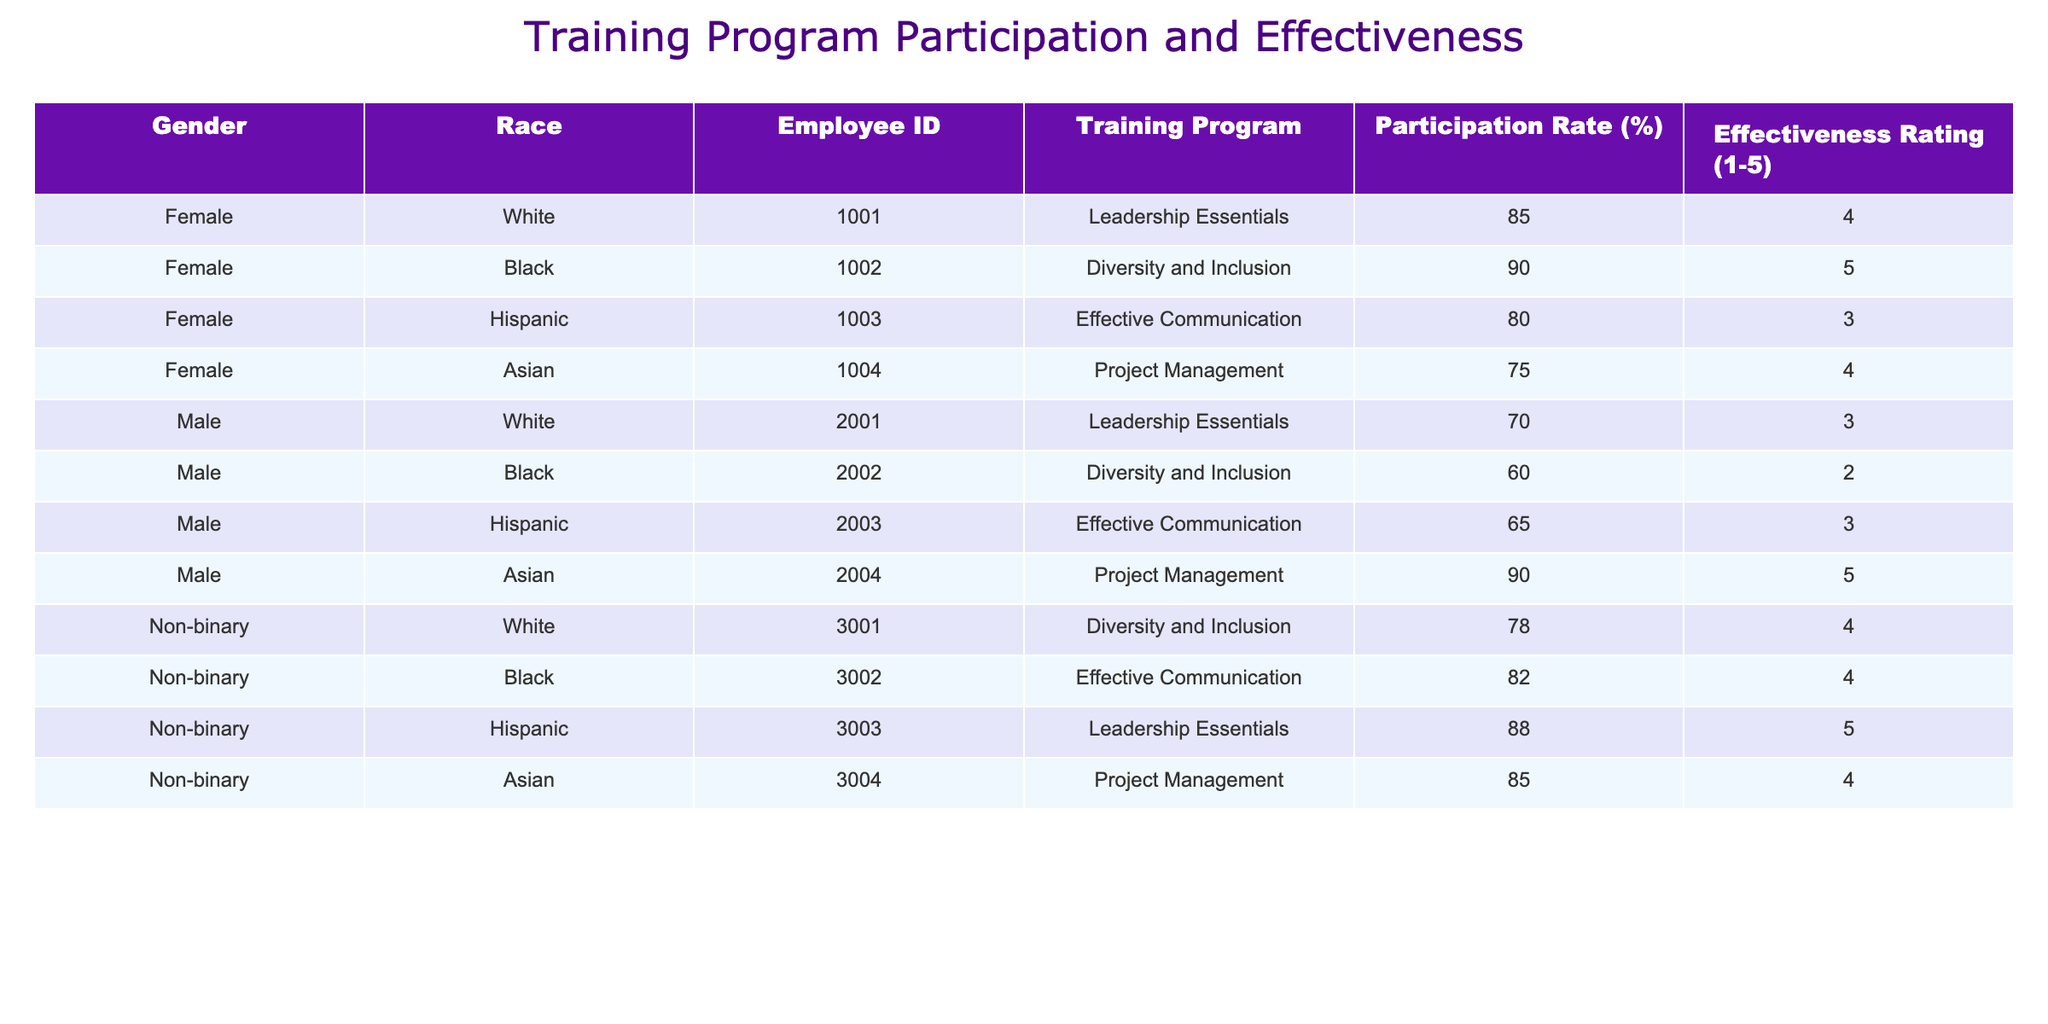What is the participation rate for Male participants in the Leadership Essentials program? From the table, I will focus on the rows where the Training Program is "Leadership Essentials" and Gender is "Male." There is one entry with a participation rate of 70%.
Answer: 70% What is the effectiveness rating for Female participants in the Diversity and Inclusion program? Checking the rows for the Diversity and Inclusion program, I find one entry for Female with an effectiveness rating of 5.
Answer: 5 What is the average participation rate for Non-binary employees? I will sum the participation rates for the Non-binary employees: 78 + 82 + 88 + 85 = 333. There are 4 Non-binary records, so the average participation rate is 333 / 4 = 83.25.
Answer: 83.25 Is the effectiveness rating higher for White participants compared to Black participants across all programs? For White participants, the effectiveness ratings are 4 (Leadership Essentials) and 4 (Diversity and Inclusion), giving an average of (4 + 4) / 2 = 4. For Black participants, the ratings are 5 (Diversity and Inclusion) and 2 (for Male), giving an average of (5 + 2) / 2 = 3.5. Since 4 is higher than 3.5, the answer is yes.
Answer: Yes What is the total effectiveness rating for participants in the Project Management program? Looking at the Project Management program, the effectiveness ratings are 4 (Female, Asian), 5 (Male, Asian), and 4 (Non-binary, Asian), summing these gives 4 + 5 + 4 = 13.
Answer: 13 